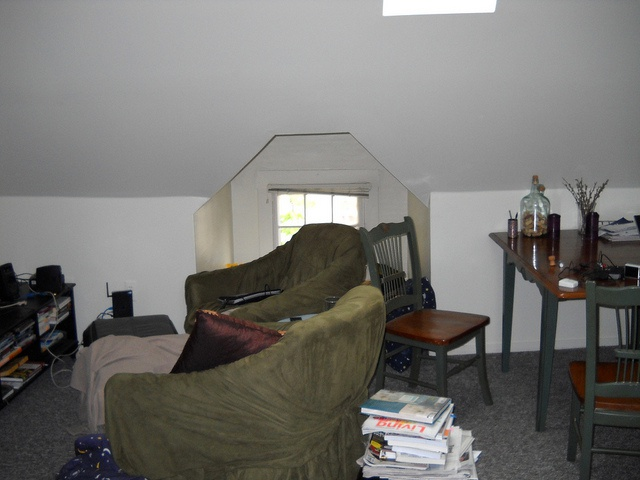Describe the objects in this image and their specific colors. I can see chair in gray, darkgreen, and black tones, chair in gray, black, and maroon tones, dining table in gray and black tones, chair in gray and black tones, and chair in gray, black, and maroon tones in this image. 